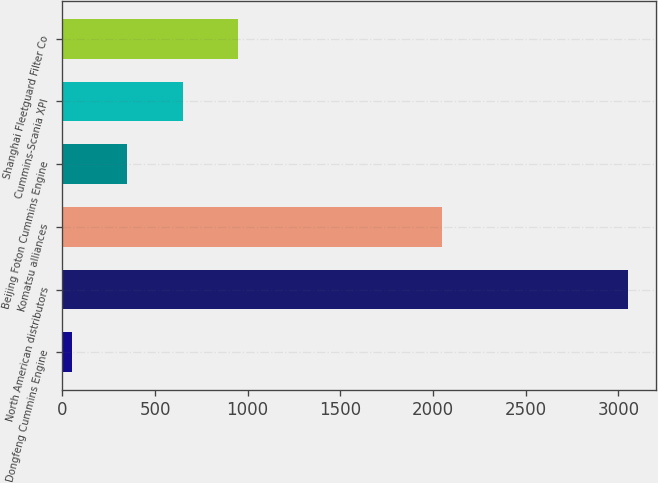Convert chart to OTSL. <chart><loc_0><loc_0><loc_500><loc_500><bar_chart><fcel>Dongfeng Cummins Engine<fcel>North American distributors<fcel>Komatsu alliances<fcel>Beijing Foton Cummins Engine<fcel>Cummins-Scania XPI<fcel>Shanghai Fleetguard Filter Co<nl><fcel>50<fcel>3050<fcel>2050<fcel>350<fcel>650<fcel>950<nl></chart> 